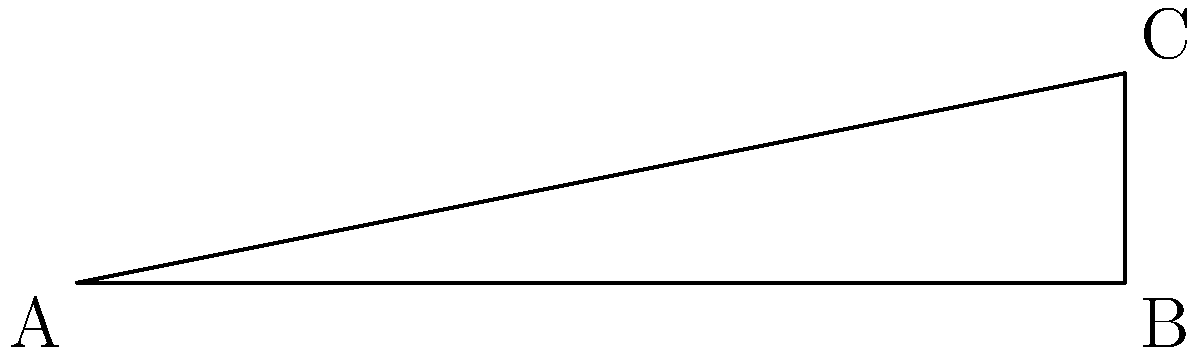As a dairy farmer, you're designing a new barn floor for proper drainage. The floor needs to slope from one end to the other, with a length of 100 meters and a height difference of 20 meters. What is the angle of slope ($\theta$) in degrees? To find the angle of slope, we can use basic trigonometry:

1. We have a right-angled triangle with:
   - Base (adjacent) = 100 meters
   - Height (opposite) = 20 meters
   - Angle of slope = $\theta$

2. We can use the tangent function to find the angle:
   $\tan(\theta) = \frac{\text{opposite}}{\text{adjacent}} = \frac{20}{100} = 0.2$

3. To find $\theta$, we need to use the inverse tangent (arctan or $\tan^{-1}$):
   $\theta = \tan^{-1}(0.2)$

4. Using a calculator or mathematical tables:
   $\theta \approx 11.31°$

5. Rounding to the nearest tenth of a degree:
   $\theta \approx 11.3°$

This angle ensures proper drainage in the dairy barn while maintaining a comfortable slope for the cows.
Answer: 11.3° 